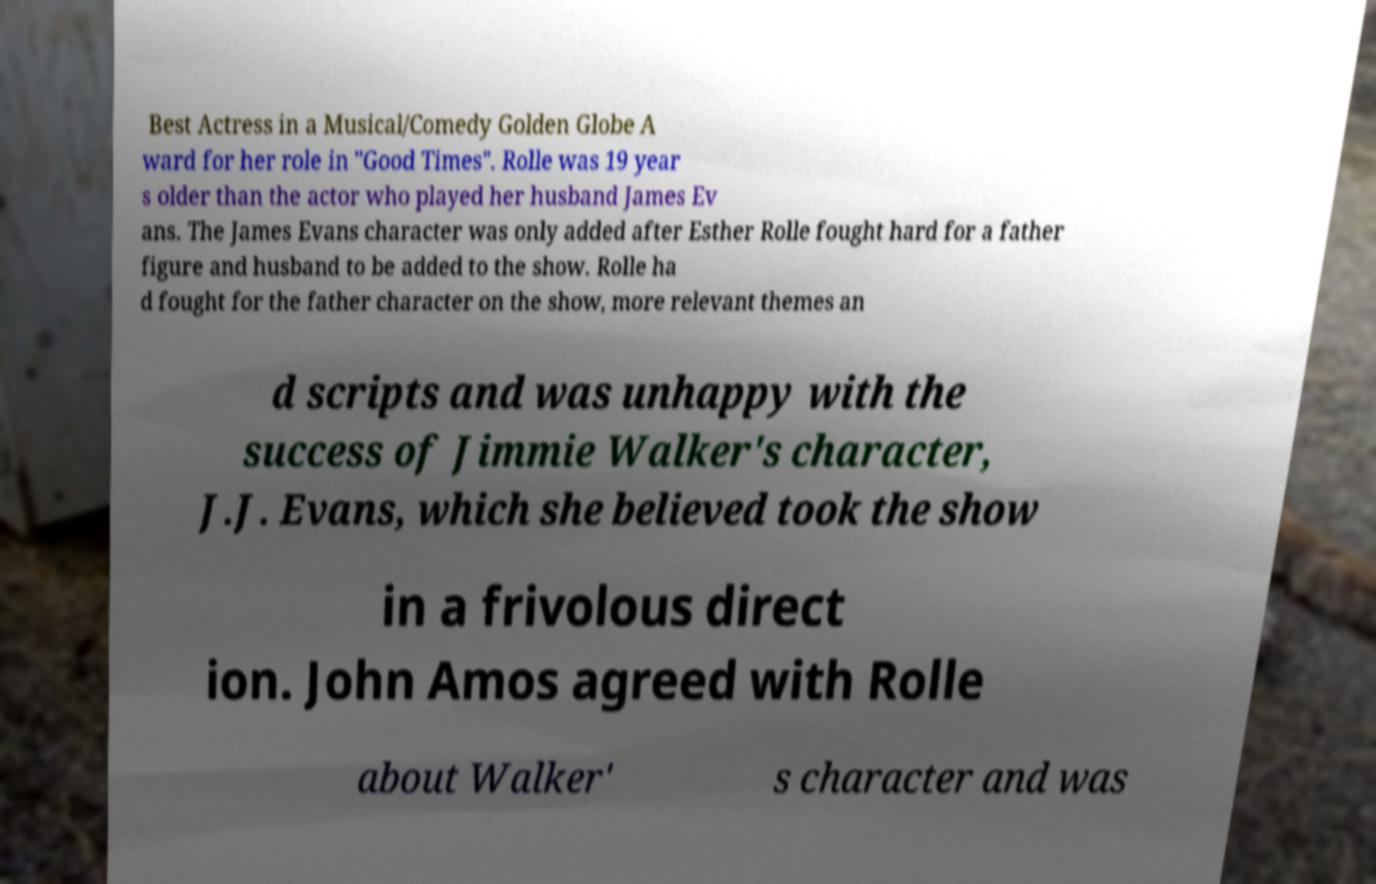Please identify and transcribe the text found in this image. Best Actress in a Musical/Comedy Golden Globe A ward for her role in "Good Times". Rolle was 19 year s older than the actor who played her husband James Ev ans. The James Evans character was only added after Esther Rolle fought hard for a father figure and husband to be added to the show. Rolle ha d fought for the father character on the show, more relevant themes an d scripts and was unhappy with the success of Jimmie Walker's character, J.J. Evans, which she believed took the show in a frivolous direct ion. John Amos agreed with Rolle about Walker' s character and was 